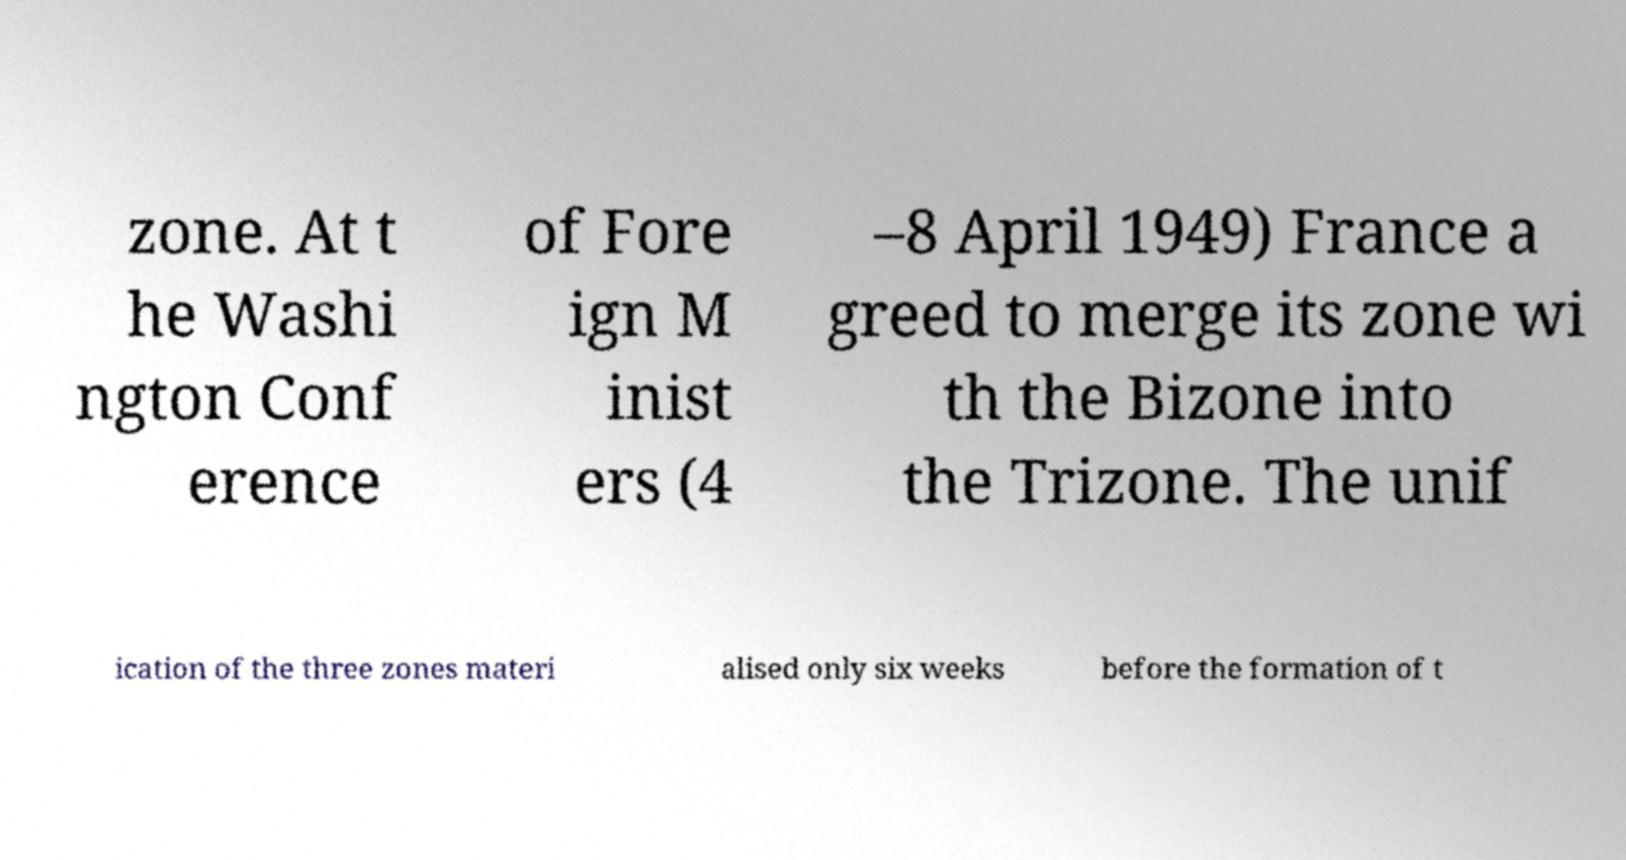Can you read and provide the text displayed in the image?This photo seems to have some interesting text. Can you extract and type it out for me? zone. At t he Washi ngton Conf erence of Fore ign M inist ers (4 –8 April 1949) France a greed to merge its zone wi th the Bizone into the Trizone. The unif ication of the three zones materi alised only six weeks before the formation of t 